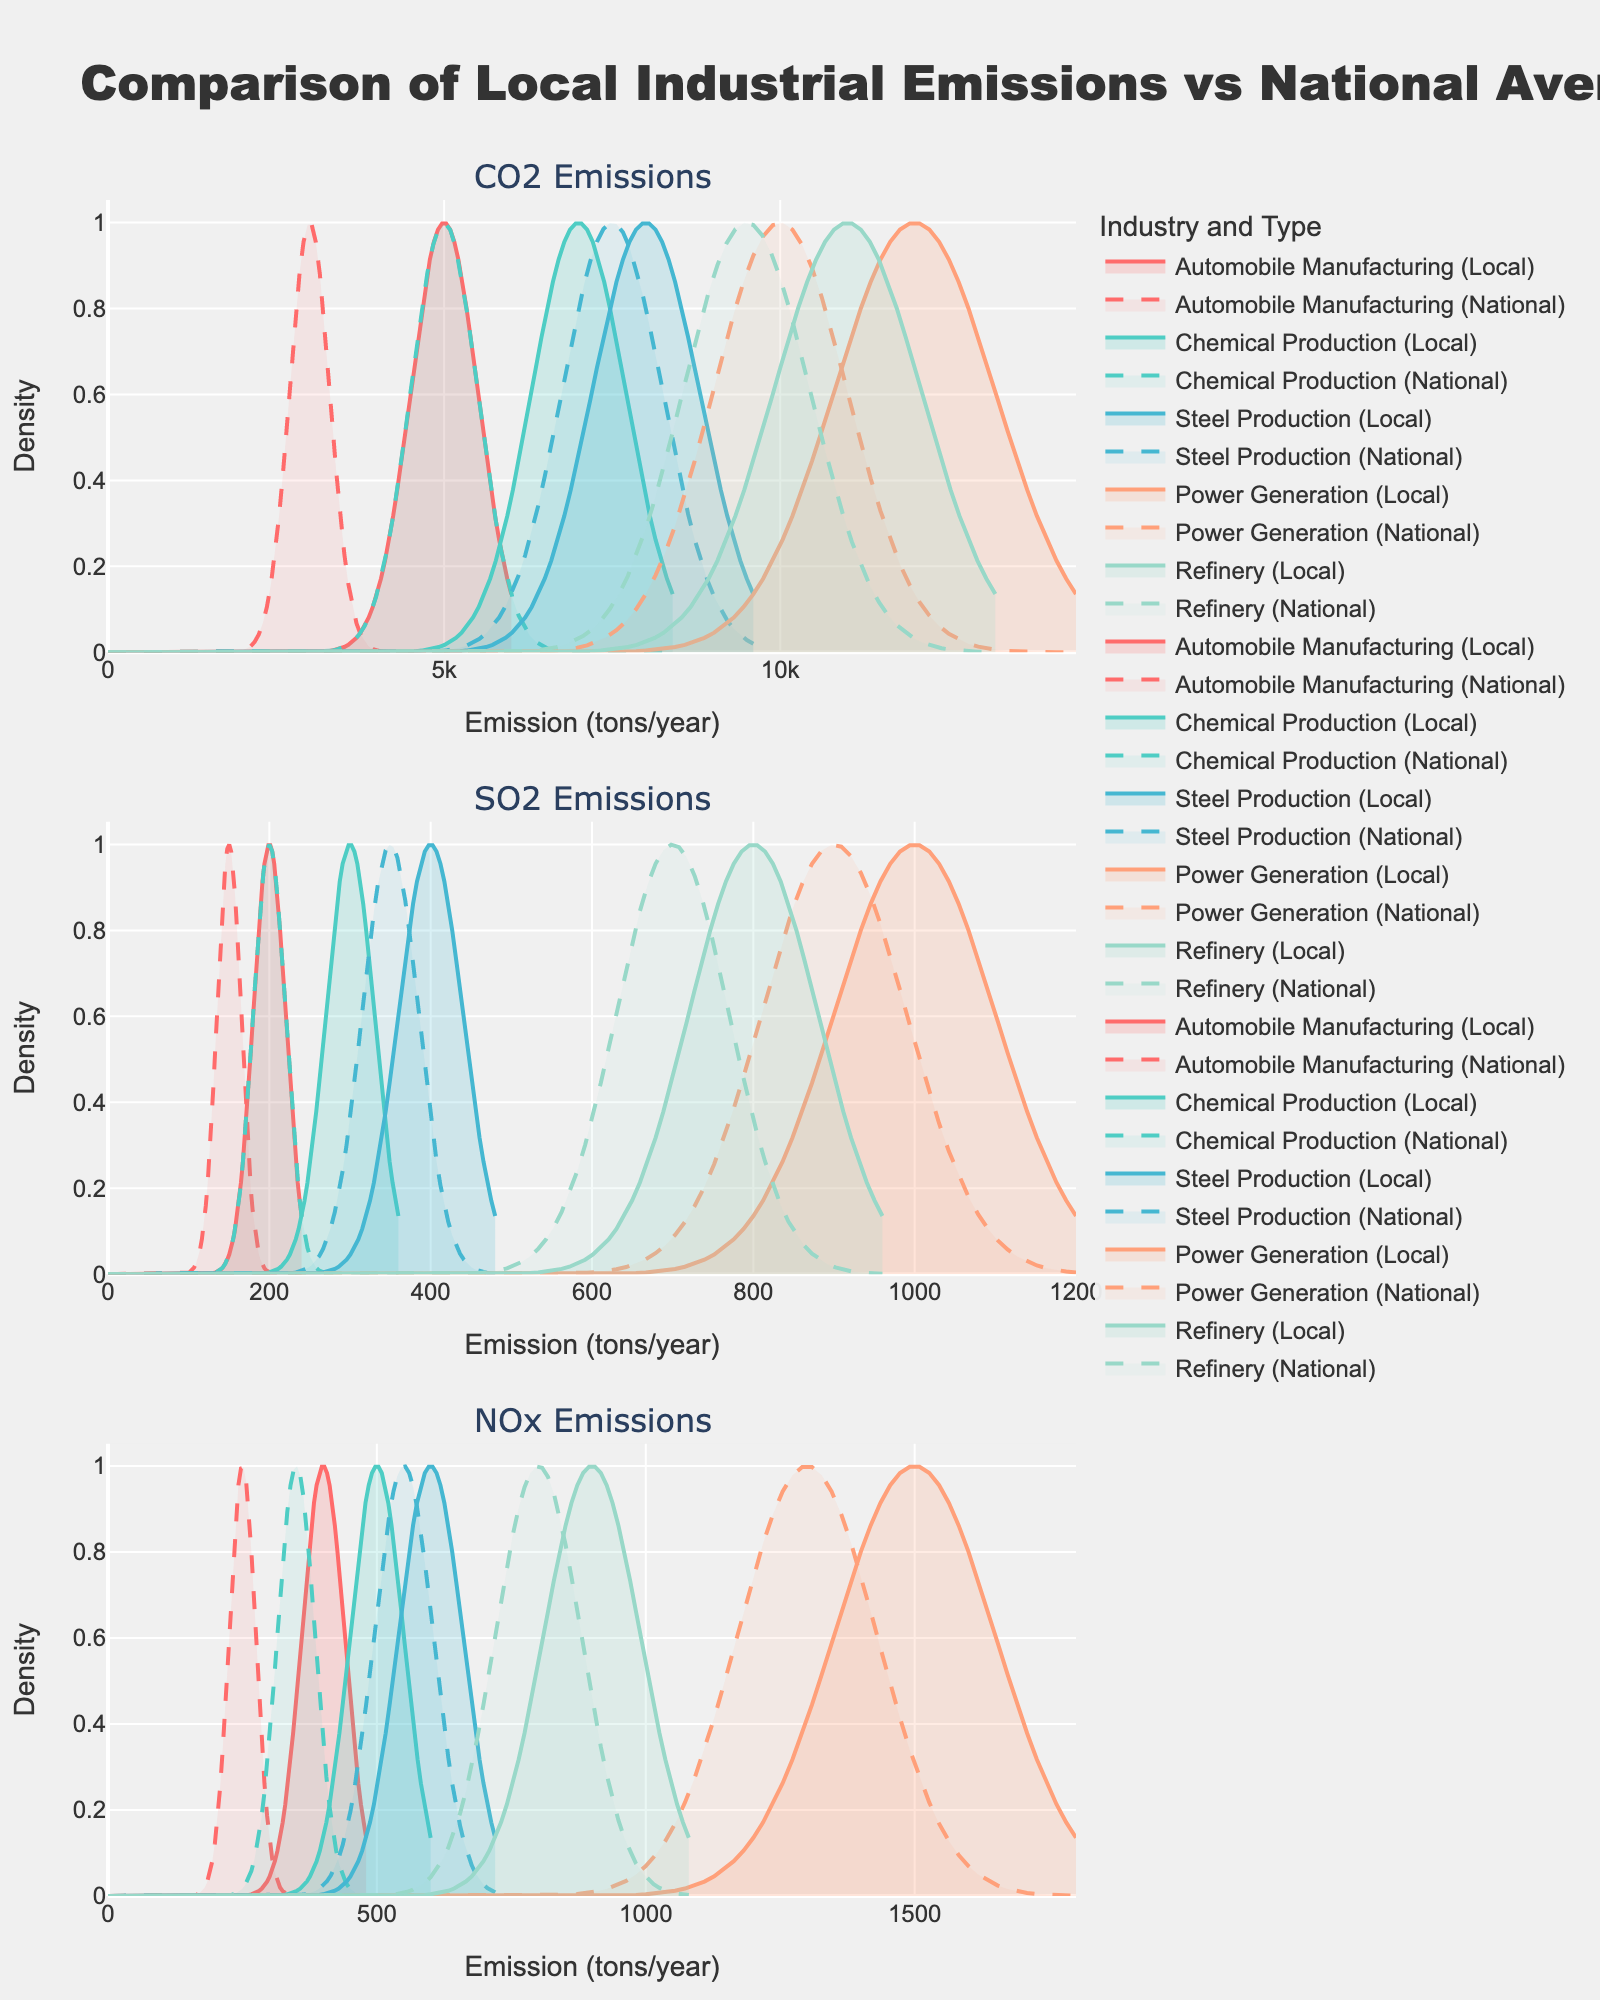How many industries are compared in the plot? There are five unique industries shown in the plot: Automobile Manufacturing, Chemical Production, Steel Production, Power Generation, and Refinery. These are listed in the subplot titles and legends.
Answer: Five What is the highest local CO2 emission among all industries? Looking at the subplot for CO2 emissions, the Power Generation industry has the highest local emission, which reaches 12000 tons/year.
Answer: 12000 tons/year How does the local emission of SO2 for Refinery compare to the national average? In the SO2 emissions subplot, the local emission for Refinery is 800 tons/year, whereas the national average is 700 tons/year. Thus, the local emission is higher by 100 tons/year.
Answer: Local is higher by 100 tons/year Which industry has the smallest difference between local and national average NOx emissions? Examining the NOx emissions subplot, Steel Production and Refinery have the smallest differences. Steel Production has local and national emissions of 600 and 550 tons/year respectively, a difference of 50 tons/year. For Refinery, the local and national emissions are 900 and 800 tons/year respectively, a difference of 100 tons/year. Thus, Steel Production has the smallest difference.
Answer: Steel Production Are the local CO2 emissions for Automobile Manufacturing higher or lower than the national average? In the subplot for CO2 emissions, the local emissions for Automobile Manufacturing are 5000 tons/year, and the national average is 3000 tons/year. Therefore, local emissions are higher than the national average.
Answer: Higher What can you say about the density curve shape for NOx emissions in the Chemical Production industry? The density curve for local NOx emissions in the Chemical Production industry is centered at around 500 tons/year and shows a peak that is narrower compared to the national average. This indicates a higher concentration around the local emission value.
Answer: Narrower peak around 500 tons/year Which industry’s local SO2 emissions are most discrepant from the national average? The plot shows that power generation has the highest discrepancy in SO2 emissions. The local SO2 emissions for Power Generation are 1000 tons/year, whereas the national average is 900 tons/year, resulting in a discrepancy of 100 tons/year, which is the highest among the given data.
Answer: Power Generation Do any industries have local emissions lower than the national average for any emission type? Reviewing the subplots, no local emission values for CO2, SO2, or NOx are lower than the national averages in any industry presented. All local emissions are equal to or higher than their respective national averages.
Answer: No 